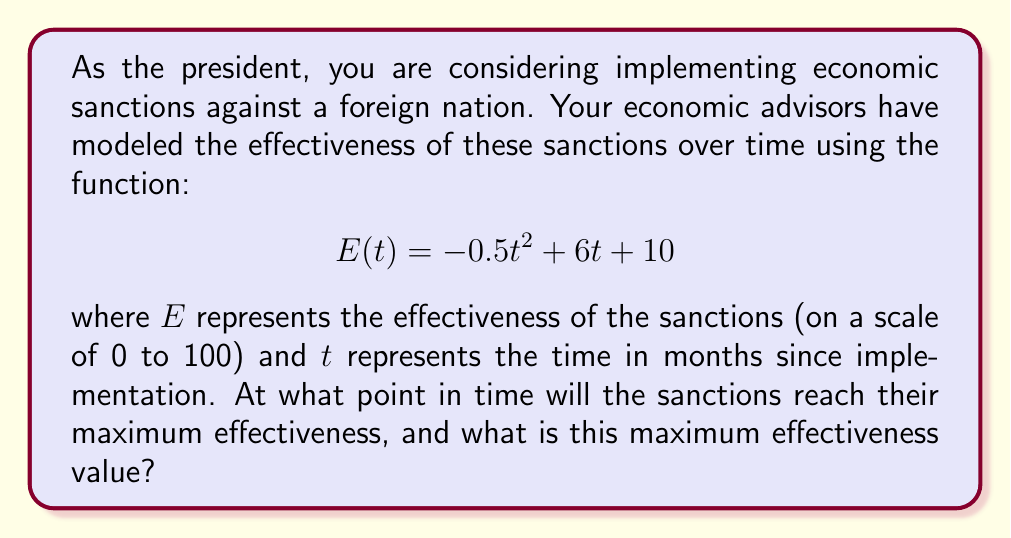Teach me how to tackle this problem. To find the maximum point of this function, we need to follow these steps:

1) First, we need to find the derivative of the function $E(t)$. This will help us determine where the function reaches its peak.

   $$E'(t) = -t + 6$$

2) To find the maximum point, we set the derivative equal to zero and solve for $t$:

   $$-t + 6 = 0$$
   $$-t = -6$$
   $$t = 6$$

3) This critical point ($t = 6$) could be a maximum or minimum. To confirm it's a maximum, we can check the second derivative:

   $$E''(t) = -1$$

   Since $E''(t)$ is negative, we confirm that $t = 6$ gives us a maximum.

4) Now that we know the time at which the sanctions are most effective (6 months), we can calculate the maximum effectiveness by plugging $t = 6$ into our original function:

   $$E(6) = -0.5(6)^2 + 6(6) + 10$$
   $$= -0.5(36) + 36 + 10$$
   $$= -18 + 36 + 10$$
   $$= 28$$

Therefore, the sanctions will reach their maximum effectiveness after 6 months, with an effectiveness value of 28 on the given scale.
Answer: The sanctions will reach their maximum effectiveness after 6 months, with a maximum effectiveness value of 28. 